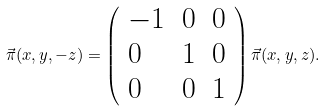Convert formula to latex. <formula><loc_0><loc_0><loc_500><loc_500>\vec { \pi } ( x , y , - z ) = \left ( \begin{array} { l l l } { - 1 } & { 0 } & { 0 } \\ { 0 } & { 1 } & { 0 } \\ { 0 } & { 0 } & { 1 } \end{array} \right ) \vec { \pi } ( x , y , z ) .</formula> 